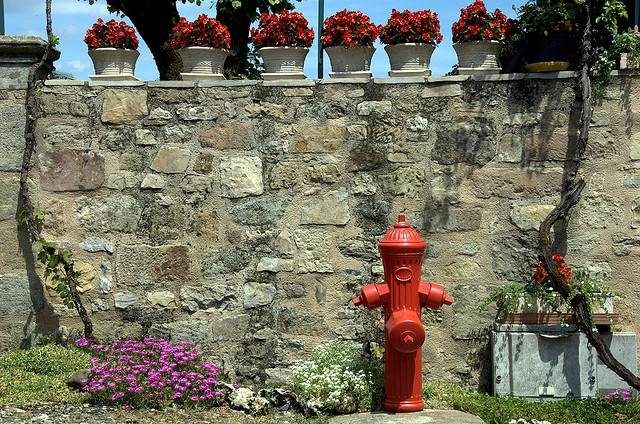Describe the objects in this image and their specific colors. I can see fire hydrant in darkblue, maroon, brown, salmon, and black tones, potted plant in darkblue, black, darkgreen, gray, and olive tones, potted plant in darkblue, black, and darkgreen tones, potted plant in darkblue, black, gray, maroon, and brown tones, and potted plant in darkblue, black, gray, maroon, and darkgreen tones in this image. 